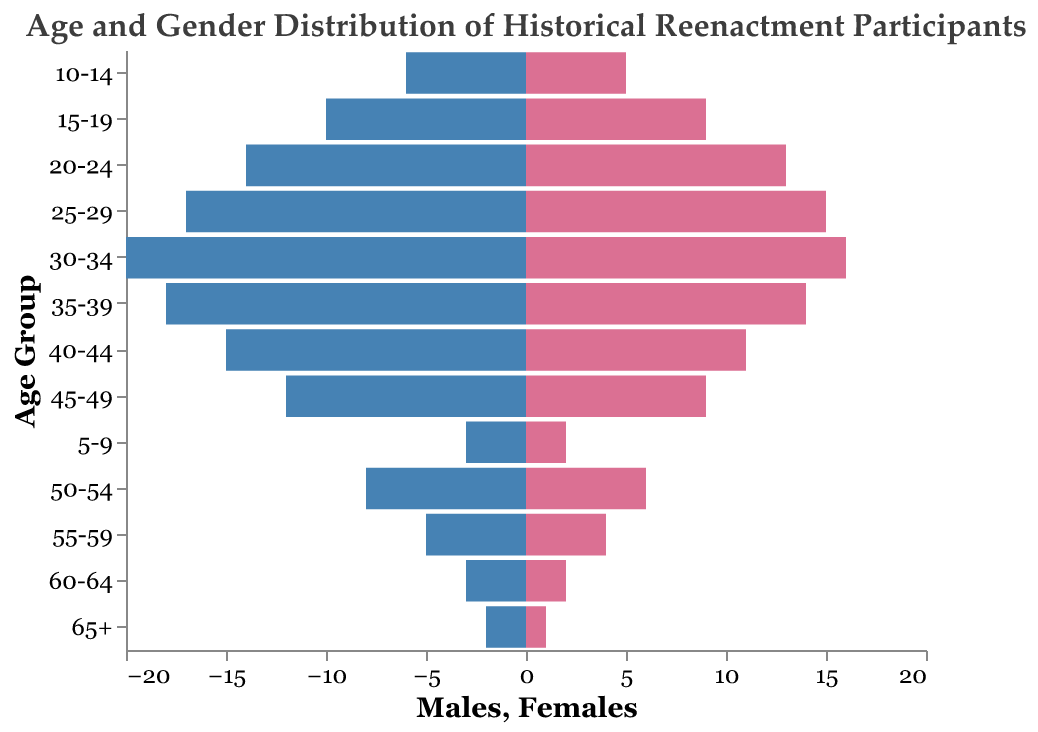What is the title of the figure? The title of a figure is usually at the top and provides a summary of what the figure represents. Here, the title is "Age and Gender Distribution of Historical Reenactment Participants" as indicated at the top of the figure.
Answer: Age and Gender Distribution of Historical Reenactment Participants What age group has the highest number of male participants? To find this, look at the bars on the left side (blue), representing male participants. The longest bar indicates the age group with the most males. The "30-34" age group has the longest bar, showing 20 male participants.
Answer: 30-34 How many female participants are in the "25-29" age group? Locate the "25-29" age group along the y-axis and find the corresponding pink bar (on the right side) for females. The value at the end of the bar shows the number of female participants, which is 15.
Answer: 15 Which age group has a greater number of participants, "45-49" or "50-54"? To compare, look at both the male and female bars for these age groups. Summarize each group's total participants. For "45-49": 12 males + 9 females = 21, and for "50-54": 8 males + 6 females = 14. Therefore, the "45-49" age group has more participants.
Answer: 45-49 Compare the number of male and female participants in the "35-39" age group. Which gender has more participants? Find the bars for the "35-39" age group. Males have a bar reaching 18, and females have a bar reaching 14. Males have more participants in this age group.
Answer: Males What is the total number of participants aged 10-14? Sum the number of males and females in the "10-14" age group. Males: 6, Females: 5. Thus, the total is 6 + 5 = 11.
Answer: 11 How does the number of male participants aged 40-44 compare to those aged 65+? Compare the blue bars for the "40-44" and "65+" age groups. The "40-44" group has 15 males, while the "65+" group has 2 males. The "40-44" group has more male participants.
Answer: 40-44 has more Identify the age group with the smallest number of total participants. To find this, sum the male and female numbers for all age groups and compare. The "65+" age group has 2 males + 1 female = 3 participants, which is the smallest number.
Answer: 65+ What is the total number of participants in the "30-34" age group? Sum the number of males and females in the "30-34" age group. Males: 20, Females: 16. Total is 20 + 16 = 36.
Answer: 36 How do the numbers of participants between the "45-49" and "40-44" age groups compare? Calculate the total participants for each group. "45-49": 12 males + 9 females = 21. "40-44": 15 males + 11 females = 26. The "40-44" group has more participants.
Answer: 40-44 